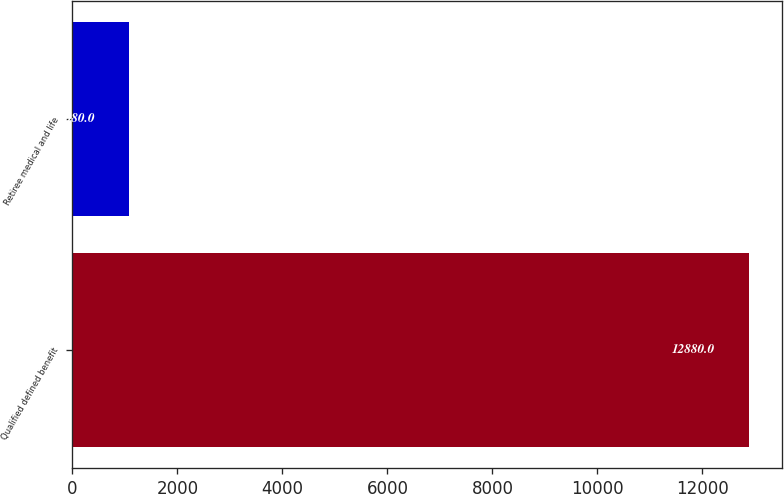Convert chart. <chart><loc_0><loc_0><loc_500><loc_500><bar_chart><fcel>Qualified defined benefit<fcel>Retiree medical and life<nl><fcel>12880<fcel>1080<nl></chart> 